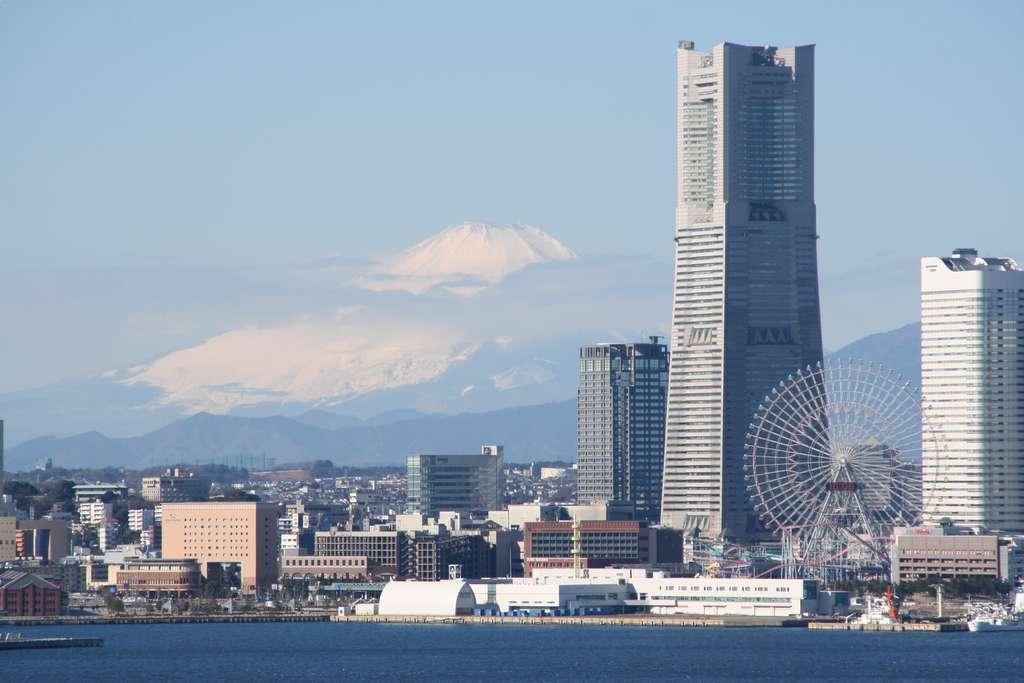Could you give a brief overview of what you see in this image? In this picture I can observe a river. There are some buildings in this picture. In the background there are mountains and a sky. 